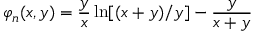Convert formula to latex. <formula><loc_0><loc_0><loc_500><loc_500>\varphi _ { n } ( x , y ) = \frac { y } { x } \ln [ ( x + y ) / y ] - \frac { y } { x + y }</formula> 